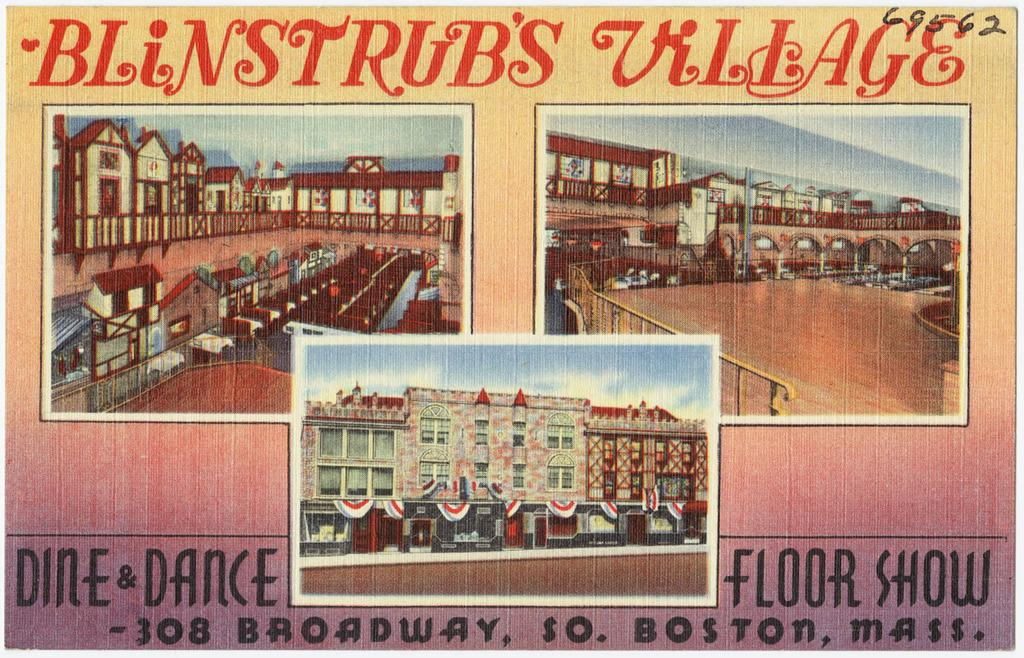<image>
Present a compact description of the photo's key features. Post card with three illustrations blinstrubs village with its boston address. 